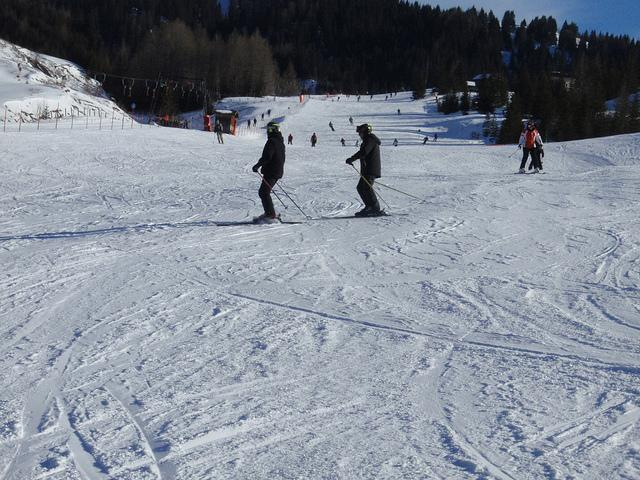Where can you most likely catch a ride nearby?

Choices:
A) ski lift
B) boat
C) elevator
D) ferris wheel ski lift 